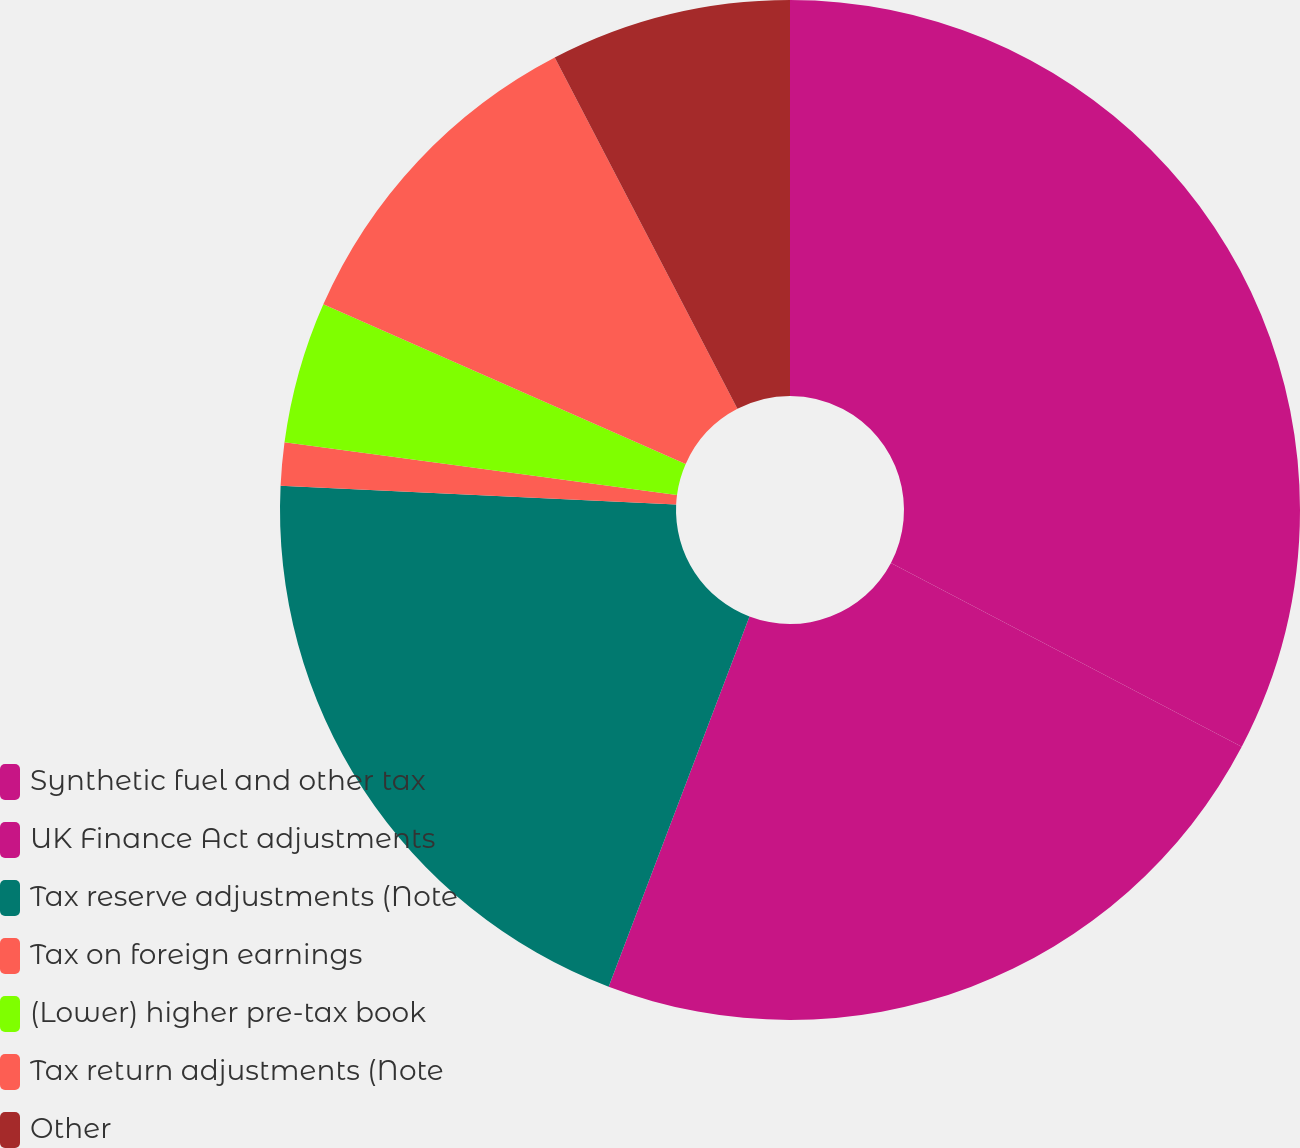Convert chart. <chart><loc_0><loc_0><loc_500><loc_500><pie_chart><fcel>Synthetic fuel and other tax<fcel>UK Finance Act adjustments<fcel>Tax reserve adjustments (Note<fcel>Tax on foreign earnings<fcel>(Lower) higher pre-tax book<fcel>Tax return adjustments (Note<fcel>Other<nl><fcel>32.68%<fcel>23.1%<fcel>19.97%<fcel>1.36%<fcel>4.49%<fcel>10.76%<fcel>7.63%<nl></chart> 